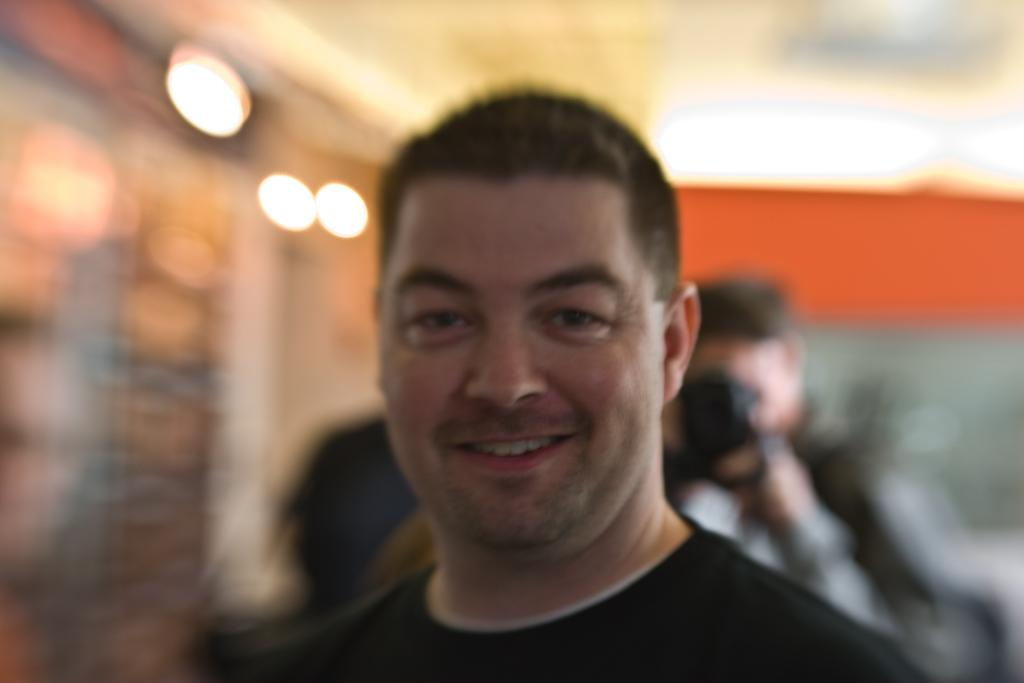Who is the main subject in the image? There is a man in the image. What is the man doing in the image? The man is smiling. What is the man wearing in the image? The man is wearing a black shirt. Can you describe the person behind the man? The person behind the man is taking a photograph. How would you describe the background of the image? The background of the image is blurry. What type of government is depicted in the image? There is no depiction of a government in the image; it features a man smiling and another person taking a photograph. What is the man using to cover his face in the image? There is no object or action in the image that suggests the man is covering his face. 